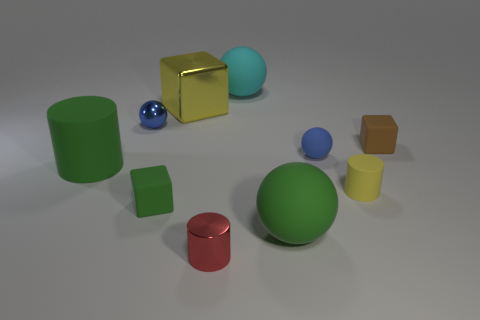Subtract all gray cylinders. How many blue balls are left? 2 Subtract all yellow cubes. How many cubes are left? 2 Subtract 2 balls. How many balls are left? 2 Subtract all green spheres. How many spheres are left? 3 Subtract all blocks. How many objects are left? 7 Subtract all blue blocks. Subtract all red balls. How many blocks are left? 3 Add 9 red cylinders. How many red cylinders are left? 10 Add 2 yellow cubes. How many yellow cubes exist? 3 Subtract 0 brown spheres. How many objects are left? 10 Subtract all large rubber spheres. Subtract all large blocks. How many objects are left? 7 